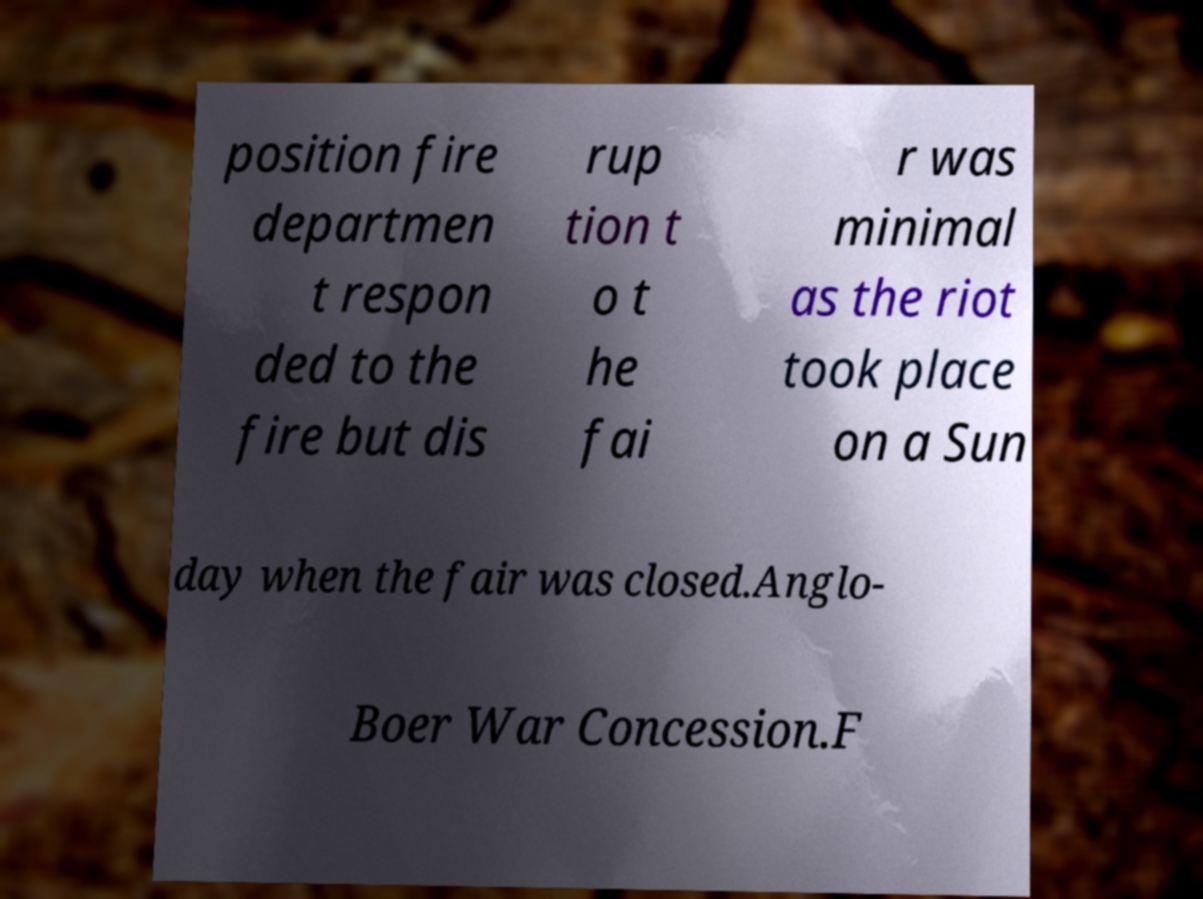For documentation purposes, I need the text within this image transcribed. Could you provide that? position fire departmen t respon ded to the fire but dis rup tion t o t he fai r was minimal as the riot took place on a Sun day when the fair was closed.Anglo- Boer War Concession.F 